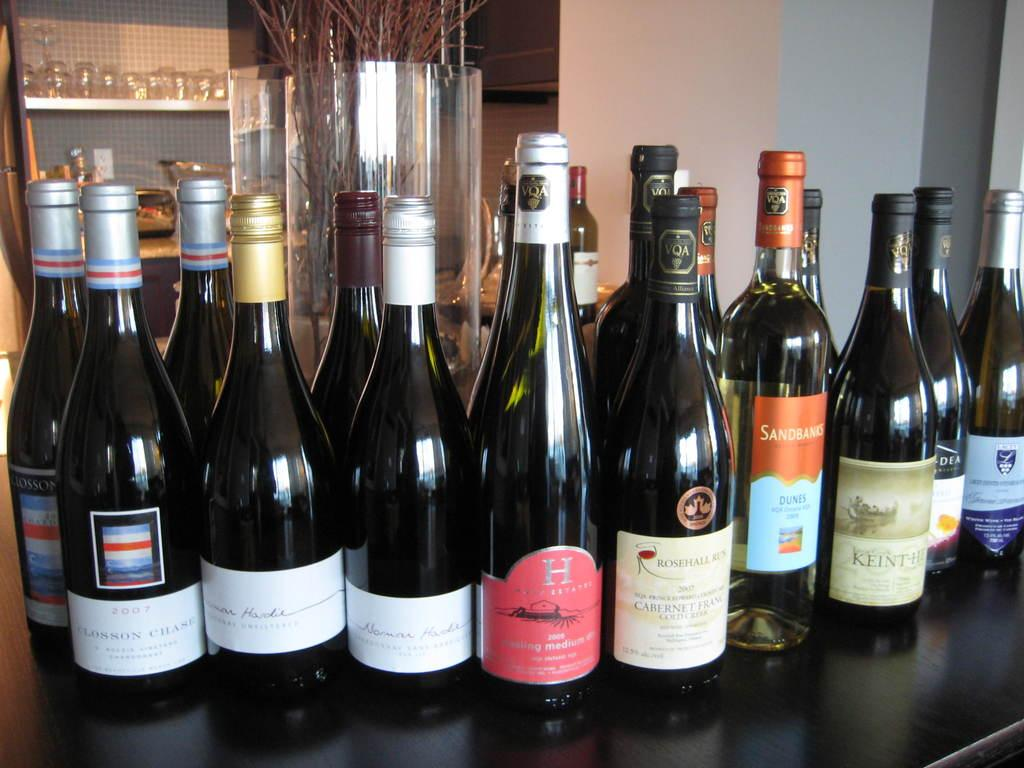<image>
Provide a brief description of the given image. The Closson Chase bottle on the far left of the shelf was made in 2007. 